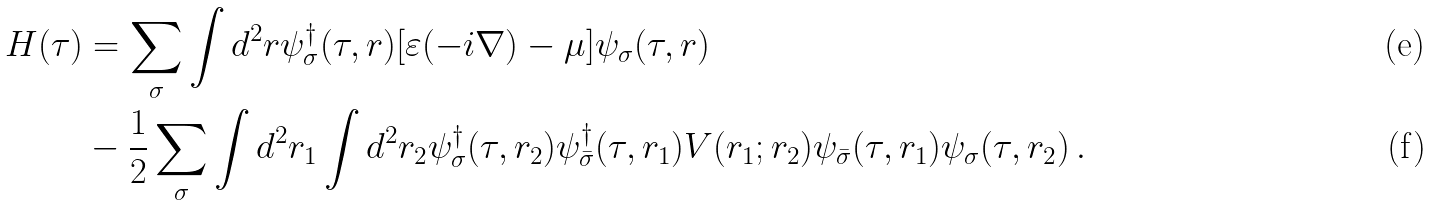Convert formula to latex. <formula><loc_0><loc_0><loc_500><loc_500>H ( \tau ) & = \sum _ { \sigma } \int d ^ { 2 } r \psi _ { \sigma } ^ { \dagger } ( \tau , { r } ) [ \varepsilon ( - i \nabla ) - \mu ] \psi _ { \sigma } ( \tau , { r } ) \\ & - \frac { 1 } { 2 } \sum _ { \sigma } \int d ^ { 2 } r _ { 1 } \int d ^ { 2 } r _ { 2 } \psi _ { \sigma } ^ { \dagger } ( \tau , { r } _ { 2 } ) \psi _ { \bar { \sigma } } ^ { \dagger } ( \tau , { r } _ { 1 } ) V ( { r } _ { 1 } ; { r } _ { 2 } ) \psi _ { \bar { \sigma } } ( \tau , { r } _ { 1 } ) \psi _ { \sigma } ( \tau , { r } _ { 2 } ) \, .</formula> 